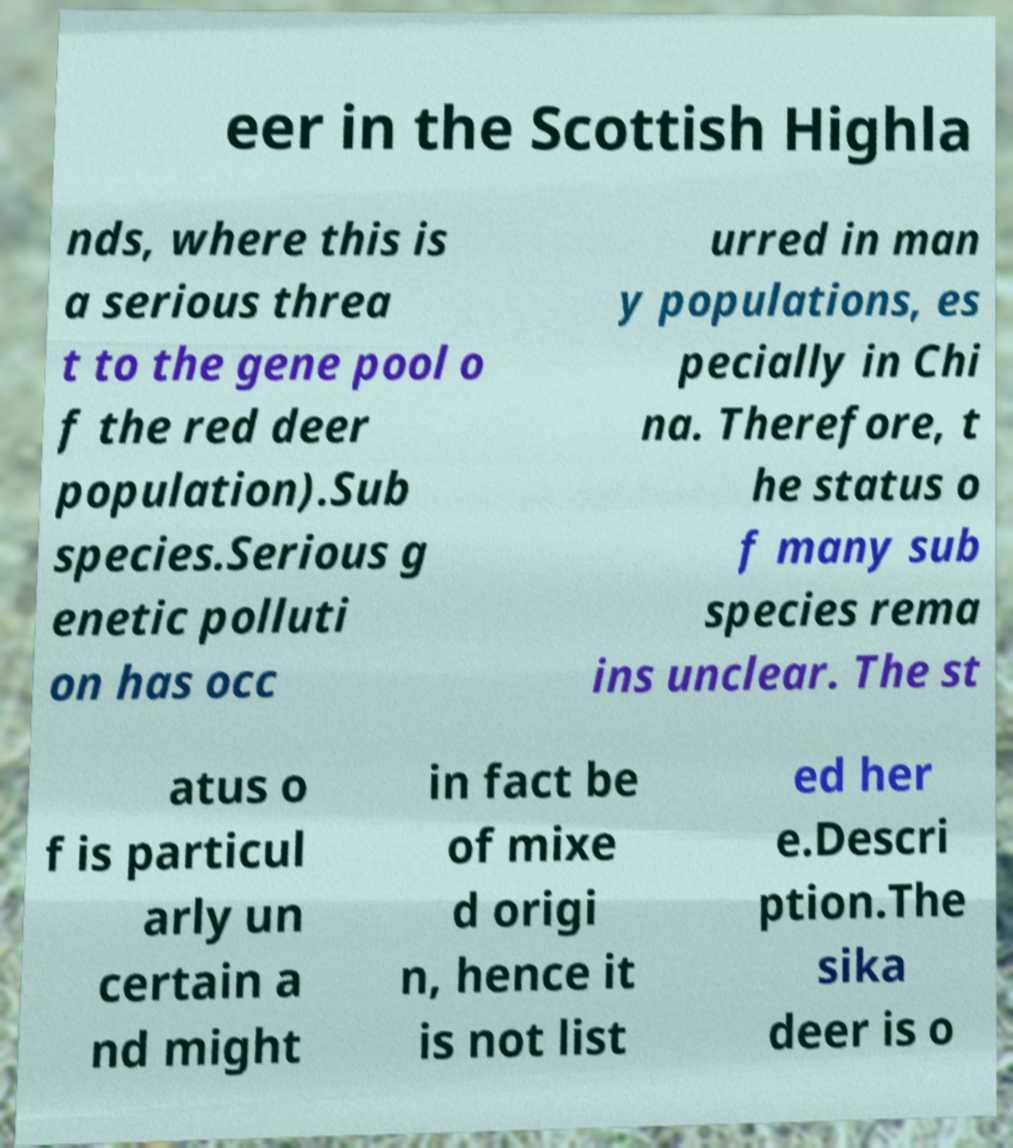Can you accurately transcribe the text from the provided image for me? eer in the Scottish Highla nds, where this is a serious threa t to the gene pool o f the red deer population).Sub species.Serious g enetic polluti on has occ urred in man y populations, es pecially in Chi na. Therefore, t he status o f many sub species rema ins unclear. The st atus o f is particul arly un certain a nd might in fact be of mixe d origi n, hence it is not list ed her e.Descri ption.The sika deer is o 